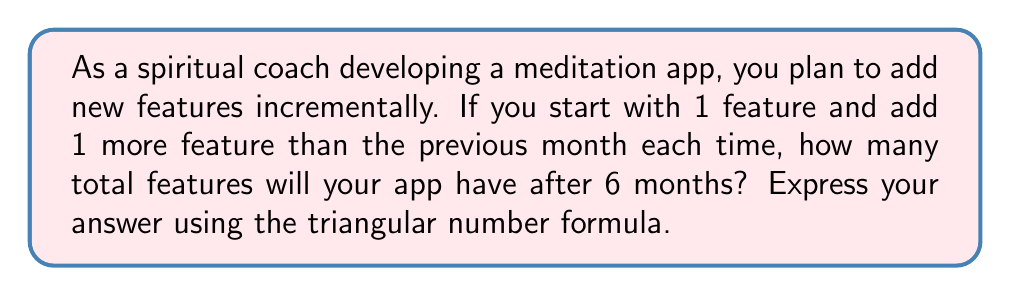Give your solution to this math problem. Let's approach this step-by-step:

1) The sequence of feature additions follows the pattern: 1, 2, 3, 4, 5, 6

2) This is an arithmetic sequence with a common difference of 1.

3) The sum of this sequence represents the total number of features after 6 months.

4) This sum is a triangular number, as it can be visualized as a triangle of dots:

   *
   * *
   * * *
   * * * *
   * * * * *
   * * * * * *

5) The formula for the nth triangular number is:

   $$T_n = \frac{n(n+1)}{2}$$

6) In this case, n = 6 (for 6 months)

7) Plugging in the values:

   $$T_6 = \frac{6(6+1)}{2} = \frac{6(7)}{2} = \frac{42}{2} = 21$$

Therefore, after 6 months, the app will have a total of 21 features.
Answer: $$\frac{6(6+1)}{2} = 21$$ features 